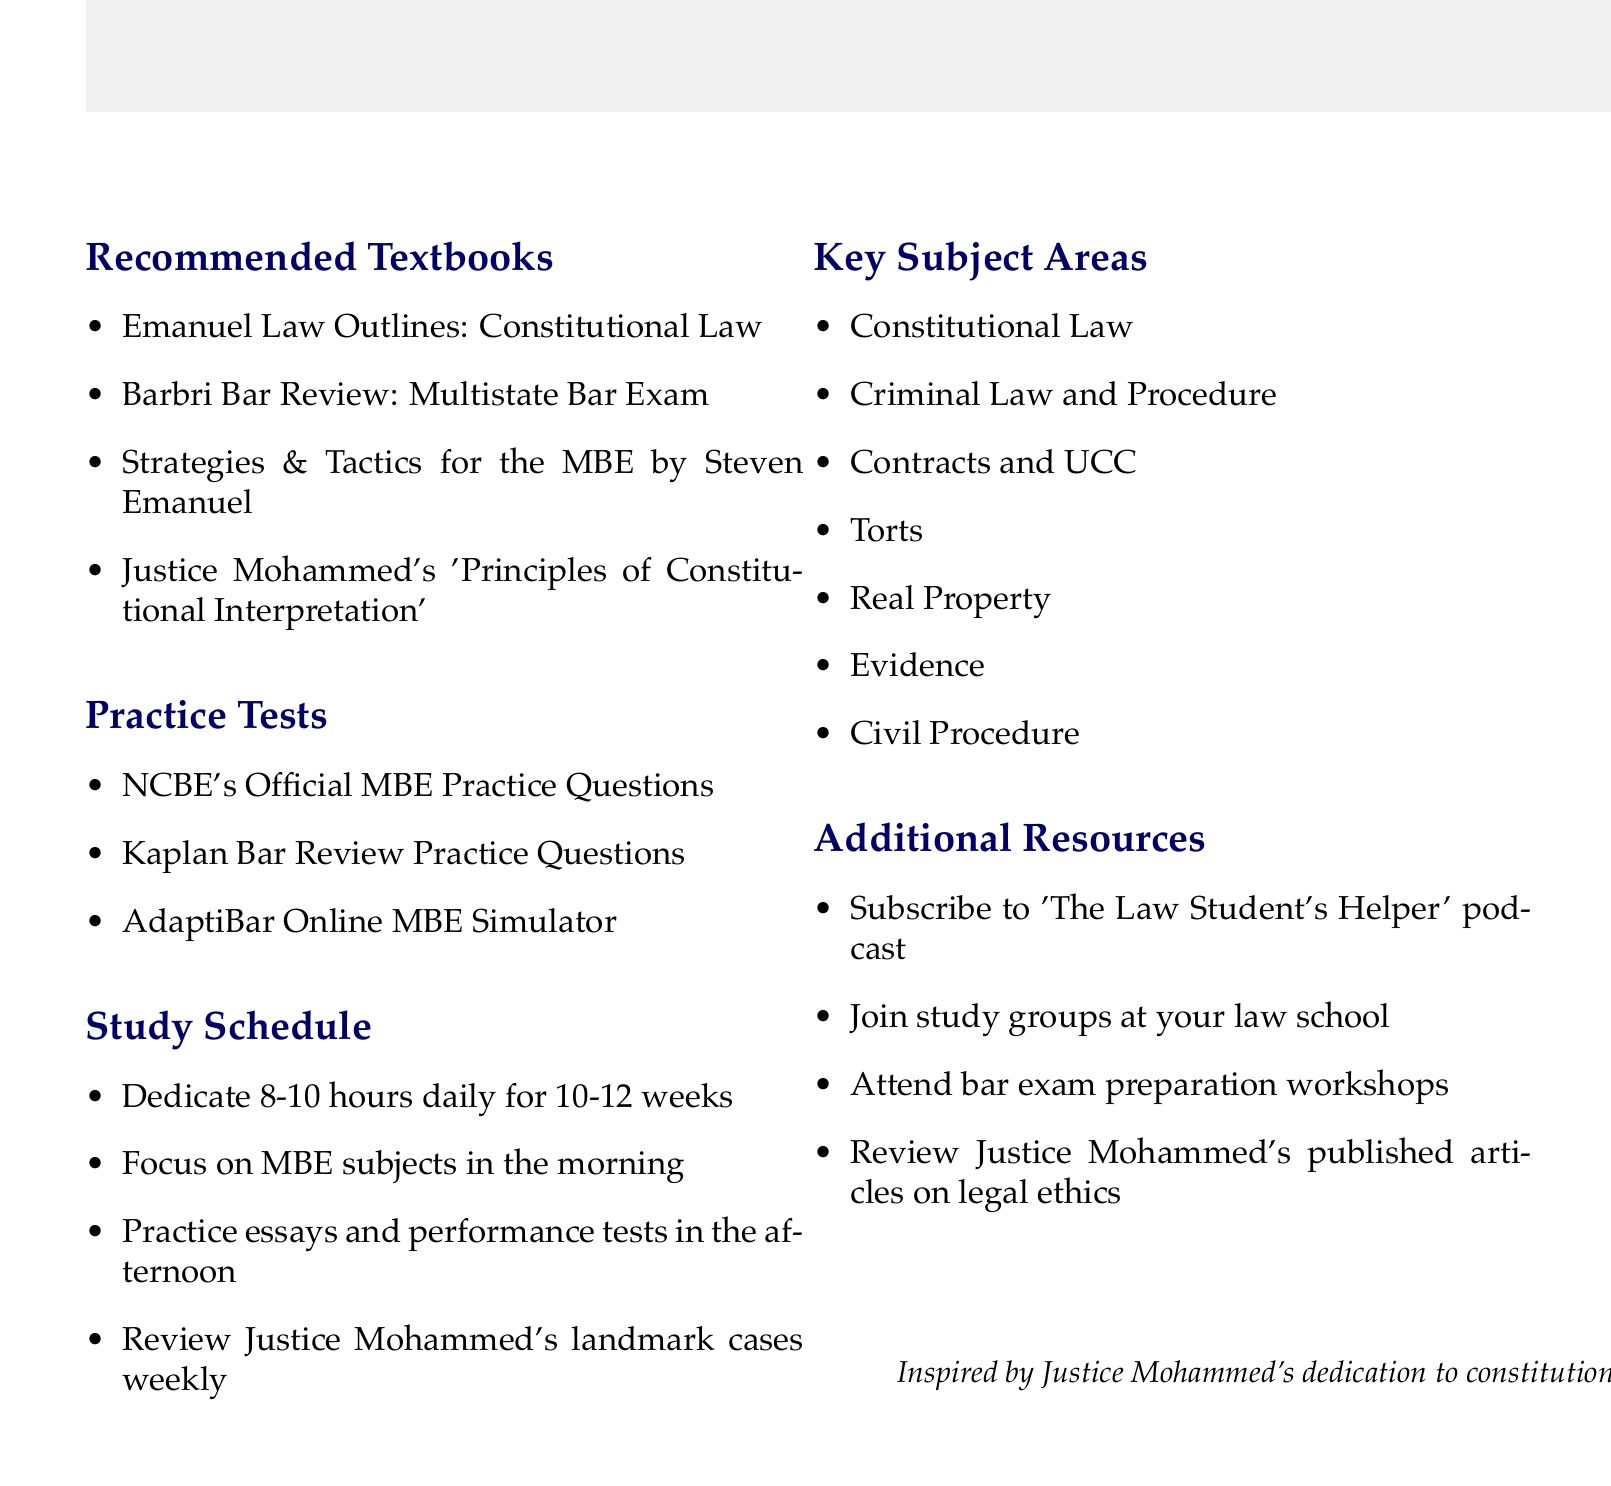What is the title of the document? The title of the document is stated at the top, indicating the primary focus of the content.
Answer: Bar Exam Preparation Study Plan How many recommended textbooks are listed? The number of recommended textbooks can be counted in the "Recommended Textbooks" section of the document.
Answer: 4 List one textbook written by Justice Mohammed. This question asks for a specific item from the "Recommended Textbooks" section, focusing on authorship.
Answer: Justice Mohammed's 'Principles of Constitutional Interpretation' What is the suggested daily study duration? The suggested daily study duration is provided in the "Study Schedule" part of the document.
Answer: 8-10 hours Which subject area involves legal processes for crime? This involves recalling a specific subject area dedicated to crime from the "Key Subject Areas" section.
Answer: Criminal Law and Procedure Name one resource for additional support listed in the document. The document lists several resources under a specific section, and this question requires recalling any of them.
Answer: 'The Law Student's Helper' podcast What is the total number of key subject areas mentioned? This question requires counting items in the "Key Subject Areas" section of the document.
Answer: 7 What type of practice test is mentioned alongside Kaplan Bar Review? This question requires recalling a specific item from the "Practice Tests" section that pairs logically with Kaplan Bar Review.
Answer: NCBE's Official MBE Practice Questions What should you focus on in the morning during study sessions? This question references a specific instruction found within the "Study Schedule" that is mentioned in regard to planning study time.
Answer: MBE subjects 